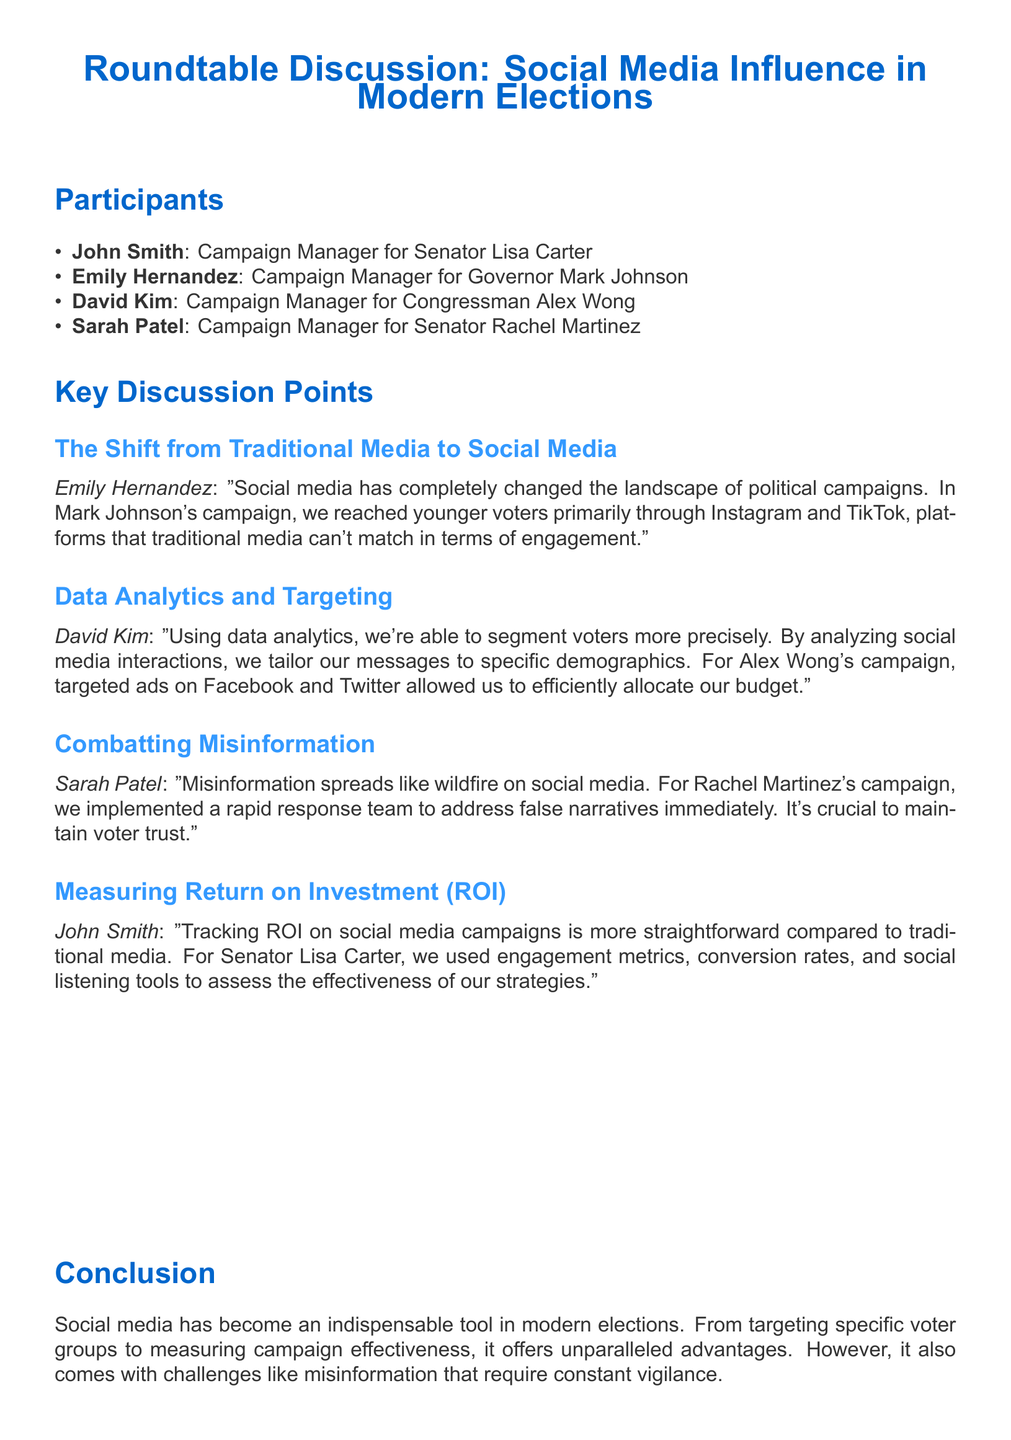What is the name of the campaign manager for Senator Lisa Carter? The document lists John Smith as the campaign manager for Senator Lisa Carter.
Answer: John Smith Which social media platforms did Emily Hernandez mention for reaching younger voters? Emily Hernandez mentioned Instagram and TikTok as platforms for reaching younger voters.
Answer: Instagram and TikTok What team did Sarah Patel implement for handling misinformation? Sarah Patel mentioned that they implemented a rapid response team to address misinformation.
Answer: Rapid response team How does David Kim use data analytics in campaigns? David Kim explained that they use data analytics to segment voters more precisely and tailor messages.
Answer: Segment voters What metrics did John Smith use to track ROI on social media campaigns? John Smith used engagement metrics, conversion rates, and social listening tools to assess ROI.
Answer: Engagement metrics, conversion rates, social listening tools Who is the campaign manager for Governor Mark Johnson? The document states that Emily Hernandez is the campaign manager for Governor Mark Johnson.
Answer: Emily Hernandez Which candidate's campaign faced challenges in maintaining voter trust? Sarah Patel indicated that maintaining voter trust was crucial for Senator Rachel Martinez's campaign.
Answer: Senator Rachel Martinez What is a major challenge of social media mentioned in the discussion? Sarah Patel highlighted that misinformation spreads rapidly on social media as a major challenge.
Answer: Misinformation In what way is return on investment on social media campaigns described compared to traditional media? John Smith described tracking ROI on social media as more straightforward than traditional media.
Answer: More straightforward 